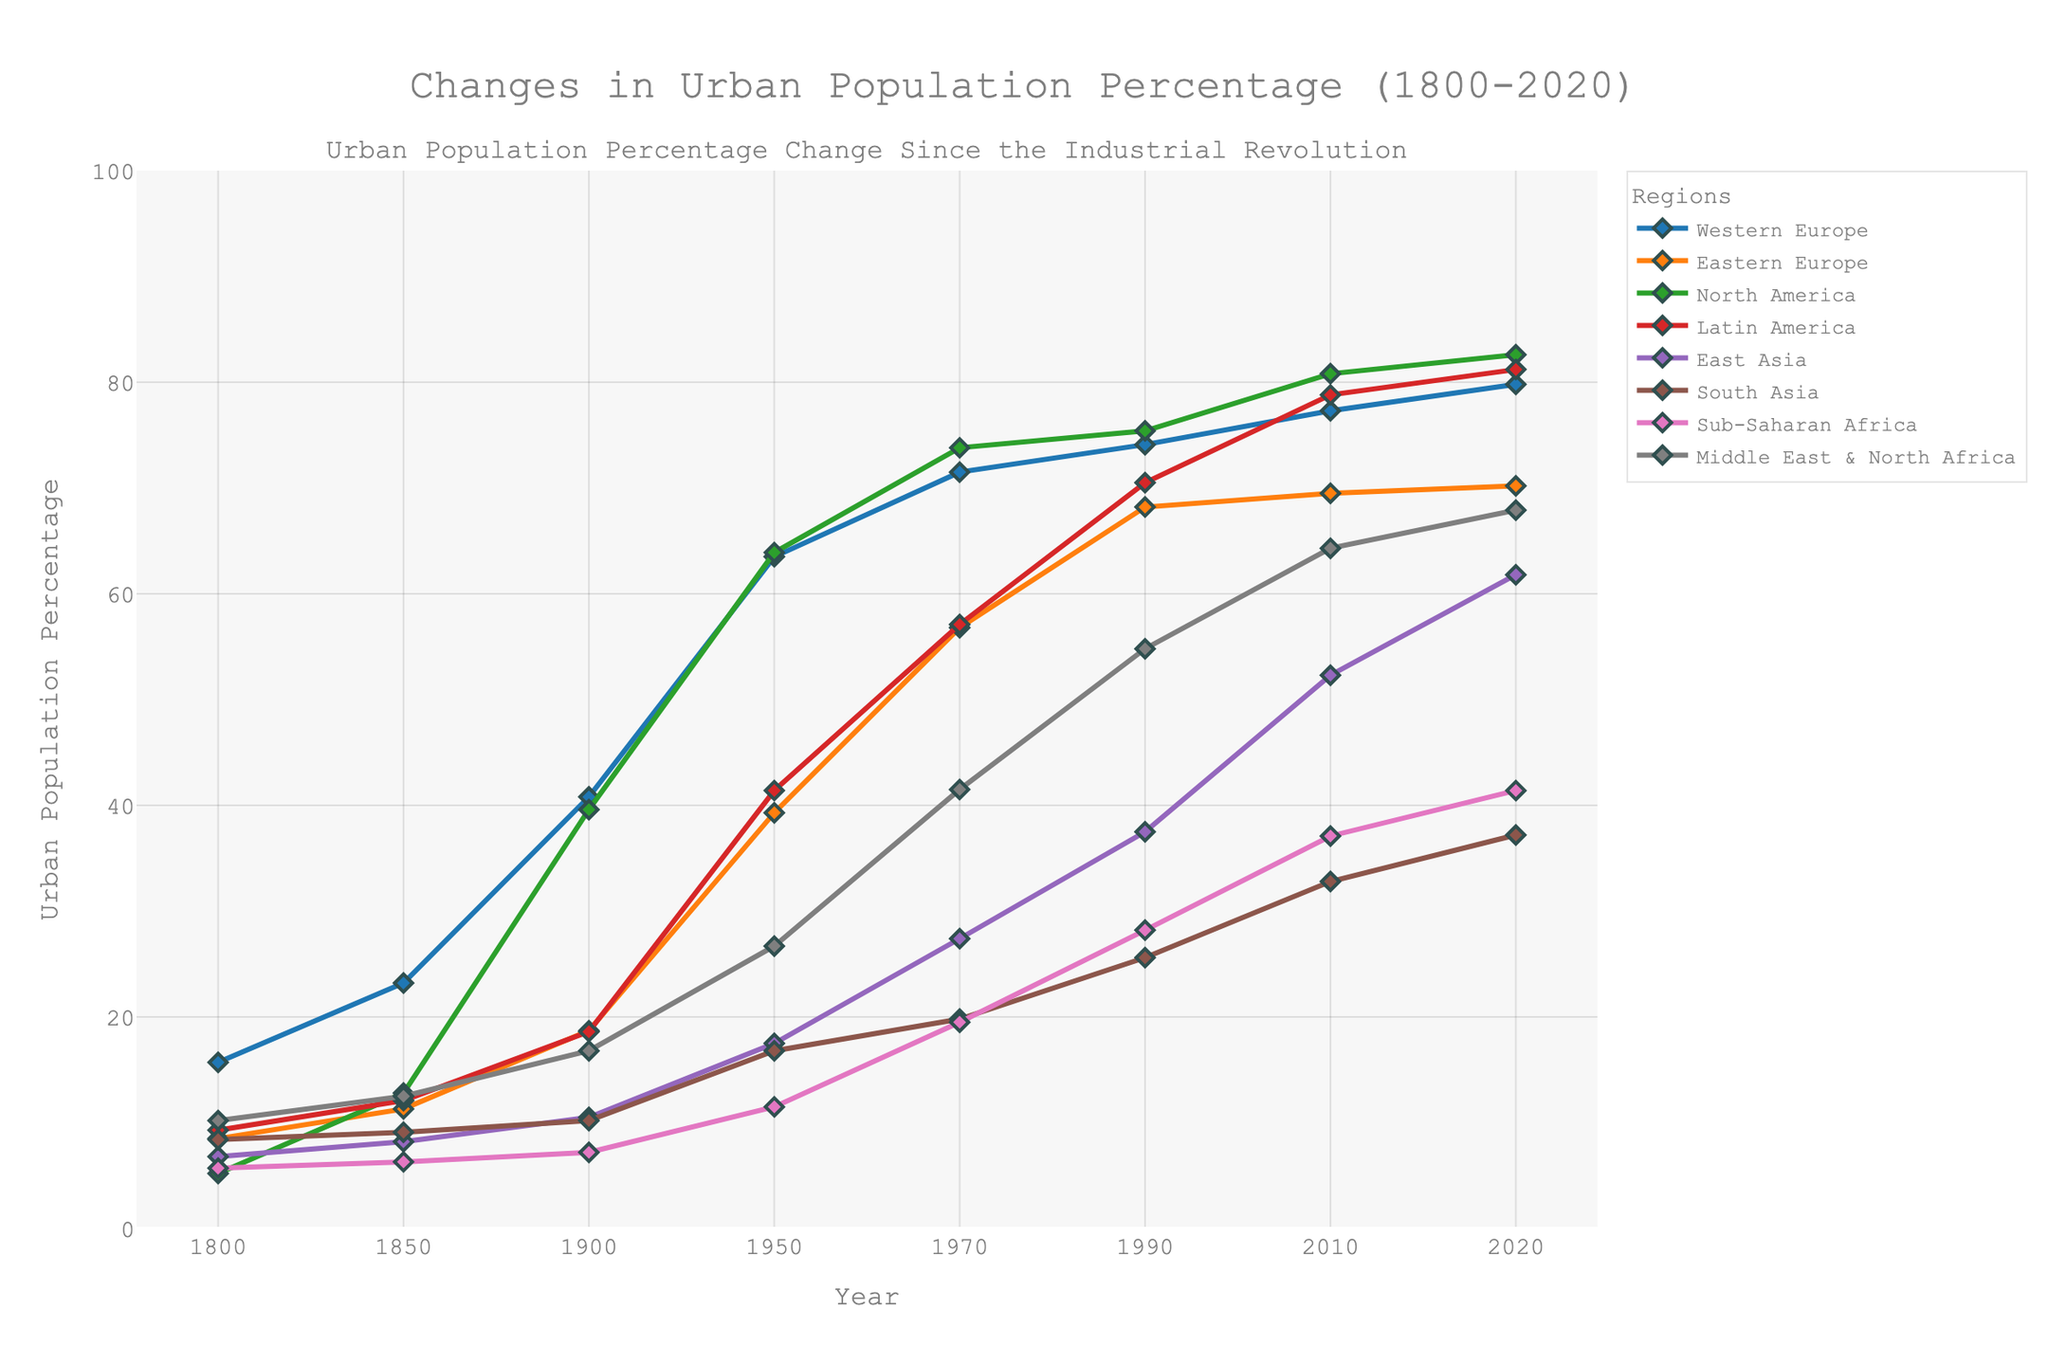What was the approximate percentage increase in the urban population of Western Europe from 1800 to 2020? To find the percentage increase, subtract the population percentage in 1800 from that in 2020 and then divide by the 1800 value. Multiply the result by 100. (79.8 - 15.7) / 15.7 * 100 = 408.28%
Answer: 408.28% Which region showed the highest percentage of urban population in 2020? By looking at the endpoints of each line in the figure for the year 2020, North America has the highest value at 82.6%.
Answer: North America From 1800 to 2020, which region had the smallest increase in urban population percentage? Examine the increase for each region from 1800 to 2020 by looking at the starting and ending points of each line. South Asia increased from 8.4% to 37.2%, with an overall increase of 28.8%, which is the smallest.
Answer: South Asia What is the range of urban population percentages for Latin America across all given years? The range is calculated by subtracting the minimum value from the maximum value for Latin America. The values are from 9.3% to 81.2%, so the range is 81.2 - 9.3 = 71.9%.
Answer: 71.9% Between 1950 and 2020, which region experienced the greatest absolute increase in urban population percentage? Find the difference in values for each region between 1950 and 2020, then determine the maximum difference. For North America, it is 82.6 - 63.9 = 18.7%; for Eastern Europe, it is 70.2 - 39.3 = 30.9%; and so on. The Middle East & North Africa experienced the greatest increase: 67.9 - 26.7 = 41.2%.
Answer: Middle East & North Africa How did the urban population percentage trend for East Asia compare with that of Sub-Saharan Africa from 1900 to 2020? Examine the slopes of the lines for East Asia and Sub-Saharan Africa from 1900 to 2020. Both exhibit increasing trends, but East Asia had a sharper rise from 10.5% to 61.8%, while Sub-Saharan Africa rose from 7.2% to 41.4%.
Answer: Both increased, but East Asia increased more sharply In which period did Western Europe see its most substantial increase in urban population percentage, and what was the change? Identify the period with the steepest rise for Western Europe. From 1900 to 1950, there is a notable increase from 40.8% to 63.5%. The change is 63.5 - 40.8 = 22.7%.
Answer: 1900 to 1950, 22.7% Which two regions had nearly similar urban population percentages in the year 1990, and what were the values? Look for lines that converge around the year 1990. Middle East & North Africa and Eastern Europe have nearly similar values, 54.8% and 68.2%, respectively.
Answer: Middle East & North Africa: 54.8%, Eastern Europe: 68.2% How did the urban population percentage of Latin America change from 1850 to 2010 compared to Eastern Europe? Find the difference for both regions between 1850 and 2010. Latin America's values are 12.1% to 78.8%, an increase of 78.8 - 12.1 = 66.7%. Eastern Europe's values are 11.3% to 69.5%, an increase of 69.5 - 11.3 = 58.2%. Latin America had a greater increase.
Answer: Latin America increased more, by 66.7% Which region had the slowest growth in urban population percentage between 1950 and 1970? Compare the difference between 1950 and 1970 for each region. South Asia's change from 16.8% to 19.8% represents the slowest growth, with an increase of 3%.
Answer: South Asia 